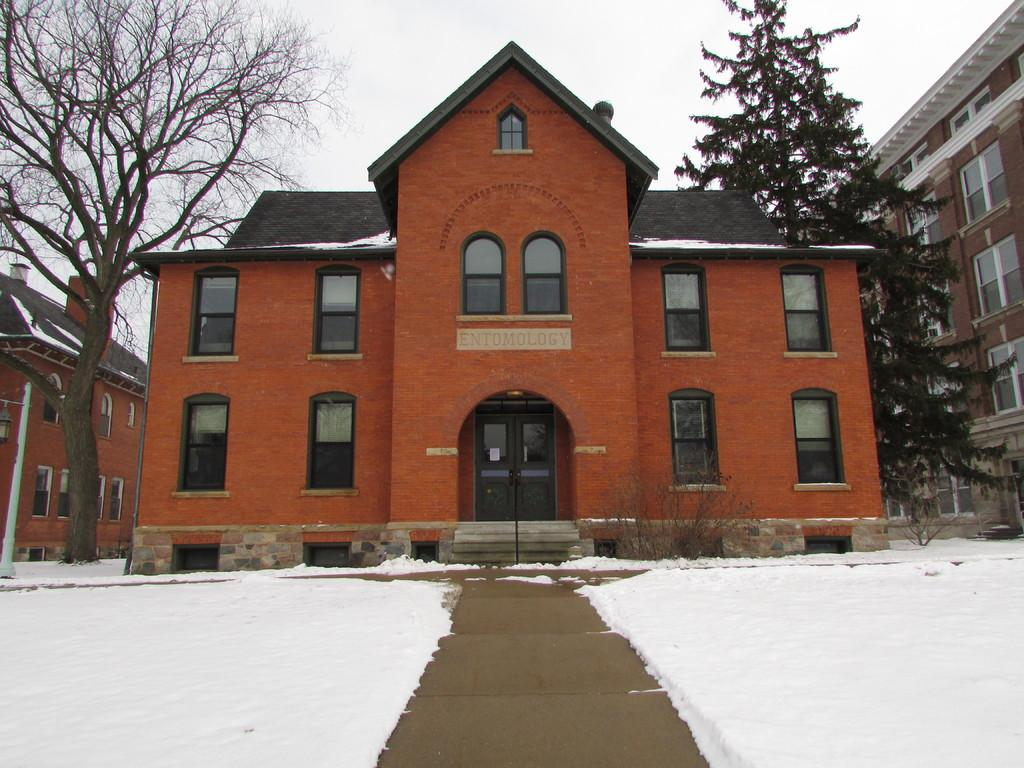What type of weather is depicted in the image? There is snow in the image, indicating a winter scene. What can be seen on the ground in the image? There is a road in the image. What type of vegetation is present in the image? There are plants and trees in the image. What type of structures are visible in the image? There are windows, a board, poles, and buildings in the image. What is visible in the background of the image? The sky is visible in the background of the image. Can you see a cap on the guitar player's head in the image? There is no guitar or guitar player present in the image. What type of self-portrait is depicted in the image? There is no self-portrait or person in the image; it is a scene of snow, a road, plants, trees, windows, a board, poles, and buildings. 